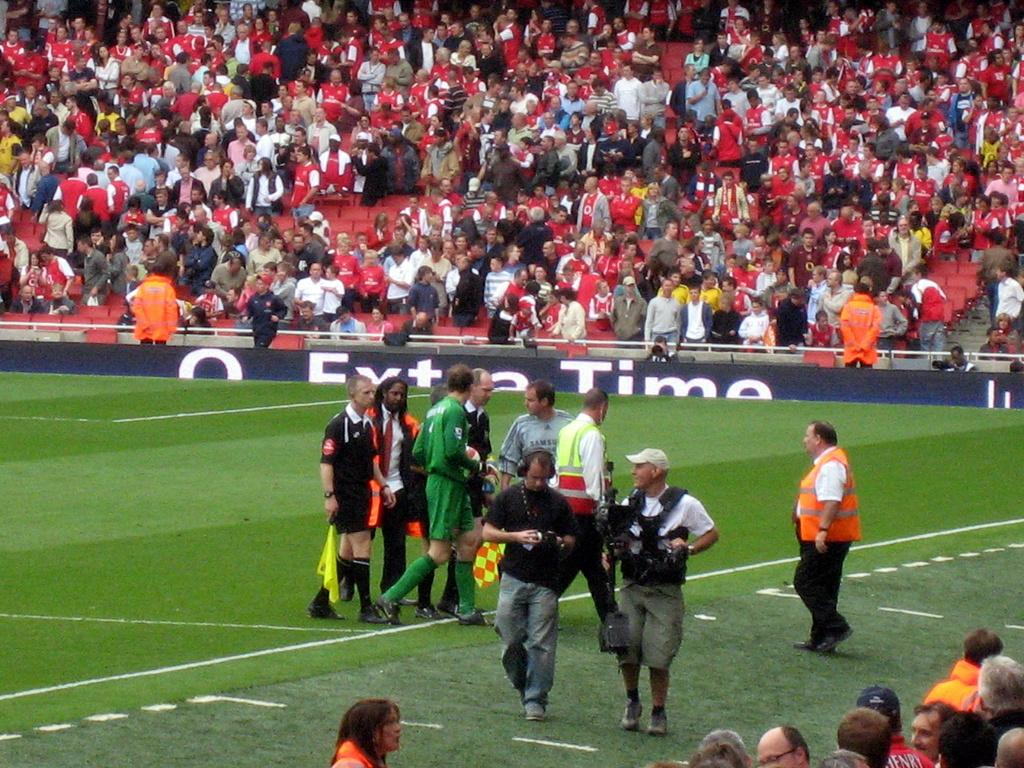<image>
Render a clear and concise summary of the photo. a staidum filled with fans and players on the field during extra time 